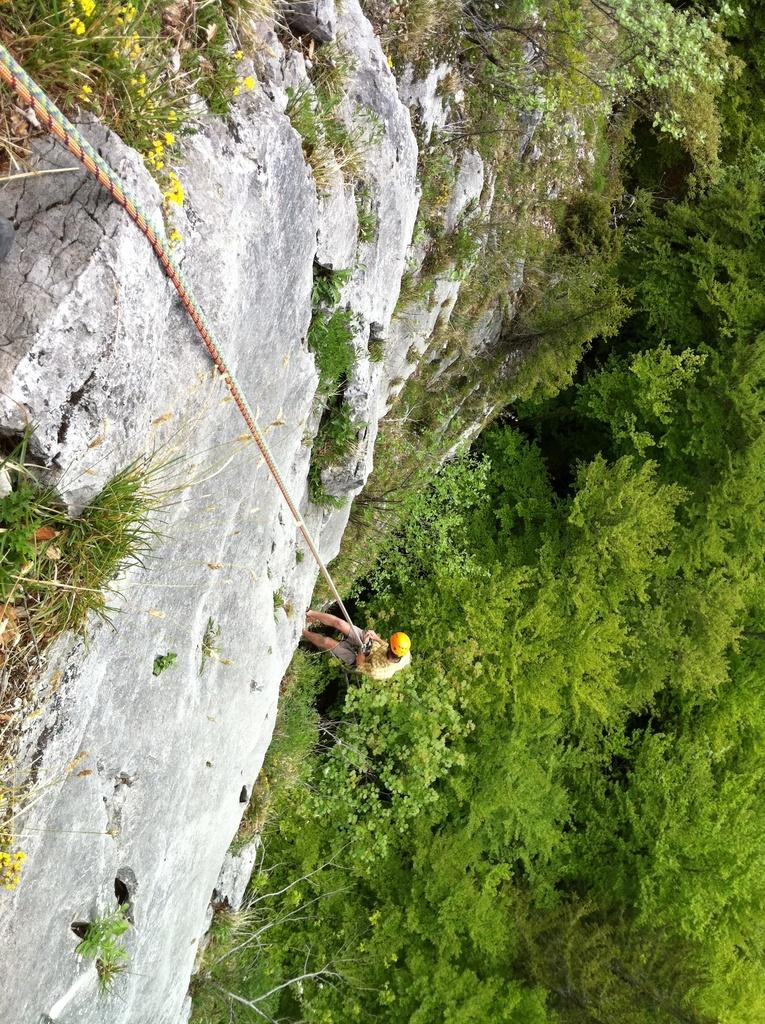What is the main subject of the image? There is a person in the image. What is the person doing in the image? The person is climbing on a rock and holding a rope. What can be seen on the right side of the image? There are trees on the right side of the image. What type of vegetation is present on the rock? There are trees and plants on the rock. What type of war is being depicted in the image? There is no war being depicted in the image; it features a person climbing on a rock while holding a rope. How many bushes are visible on the rock in the image? There is no mention of bushes in the image; it features trees and plants on the rock. 